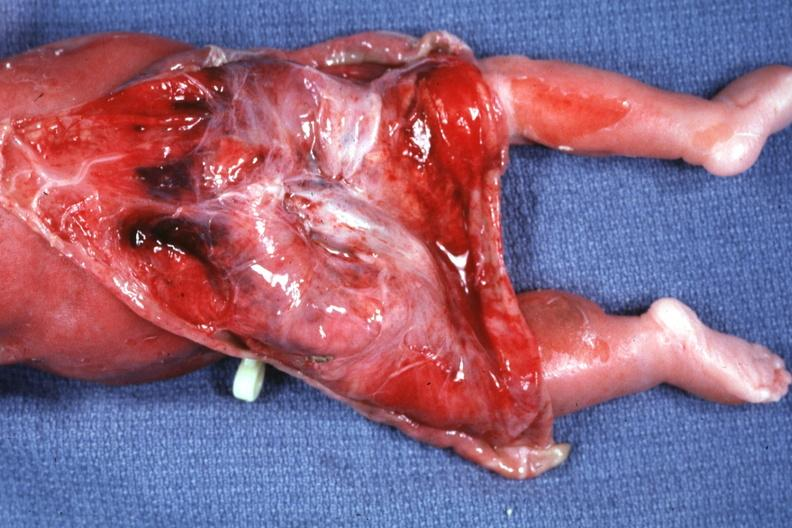does this image show skin over back a buttocks reflected to show large tumor mass?
Answer the question using a single word or phrase. Yes 